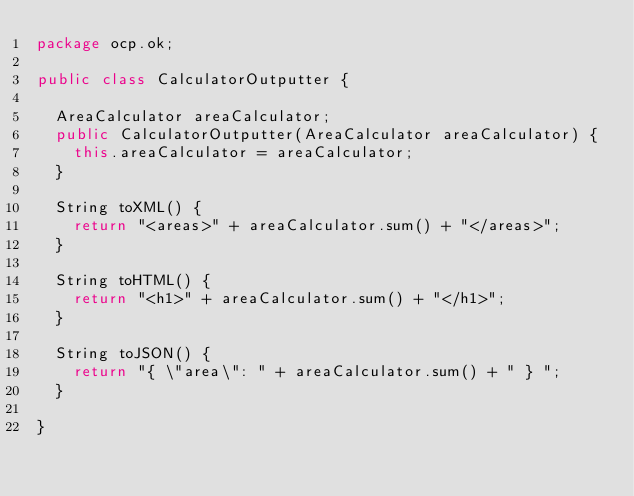Convert code to text. <code><loc_0><loc_0><loc_500><loc_500><_Java_>package ocp.ok;

public class CalculatorOutputter {

  AreaCalculator areaCalculator;
  public CalculatorOutputter(AreaCalculator areaCalculator) {
    this.areaCalculator = areaCalculator;
  }
  
  String toXML() {
    return "<areas>" + areaCalculator.sum() + "</areas>";
  }
  
  String toHTML() {
    return "<h1>" + areaCalculator.sum() + "</h1>";
  }
  
  String toJSON() {
    return "{ \"area\": " + areaCalculator.sum() + " } ";
  }

}
</code> 